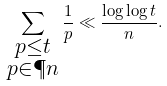Convert formula to latex. <formula><loc_0><loc_0><loc_500><loc_500>\sum _ { \substack { p \leq t \\ p \in \P n } } \frac { 1 } { p } \ll \frac { \log \log t } n .</formula> 